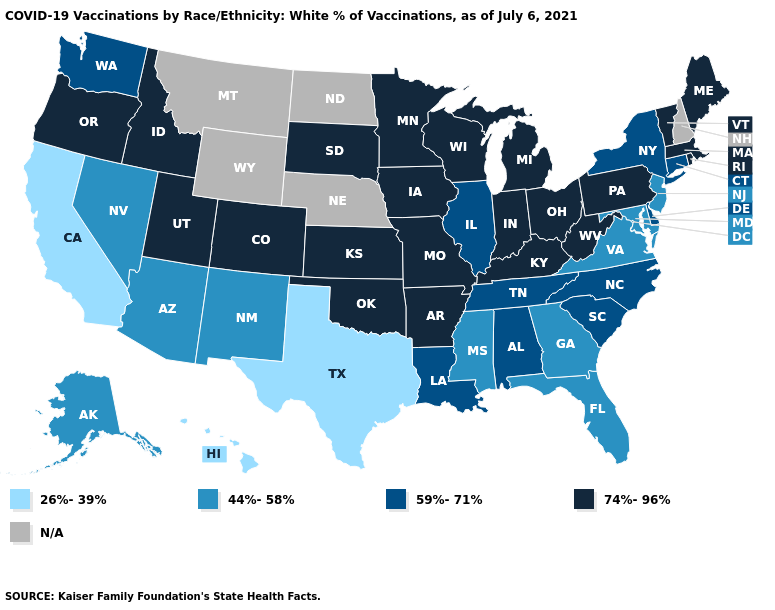Name the states that have a value in the range 59%-71%?
Give a very brief answer. Alabama, Connecticut, Delaware, Illinois, Louisiana, New York, North Carolina, South Carolina, Tennessee, Washington. Is the legend a continuous bar?
Concise answer only. No. What is the value of Connecticut?
Short answer required. 59%-71%. Which states have the lowest value in the USA?
Concise answer only. California, Hawaii, Texas. Name the states that have a value in the range 44%-58%?
Concise answer only. Alaska, Arizona, Florida, Georgia, Maryland, Mississippi, Nevada, New Jersey, New Mexico, Virginia. Name the states that have a value in the range N/A?
Short answer required. Montana, Nebraska, New Hampshire, North Dakota, Wyoming. What is the highest value in the South ?
Quick response, please. 74%-96%. Name the states that have a value in the range N/A?
Give a very brief answer. Montana, Nebraska, New Hampshire, North Dakota, Wyoming. What is the value of Nevada?
Concise answer only. 44%-58%. Which states have the lowest value in the MidWest?
Write a very short answer. Illinois. What is the value of Missouri?
Answer briefly. 74%-96%. Among the states that border North Carolina , which have the lowest value?
Concise answer only. Georgia, Virginia. What is the value of Texas?
Quick response, please. 26%-39%. What is the value of North Dakota?
Write a very short answer. N/A. Does the first symbol in the legend represent the smallest category?
Write a very short answer. Yes. 